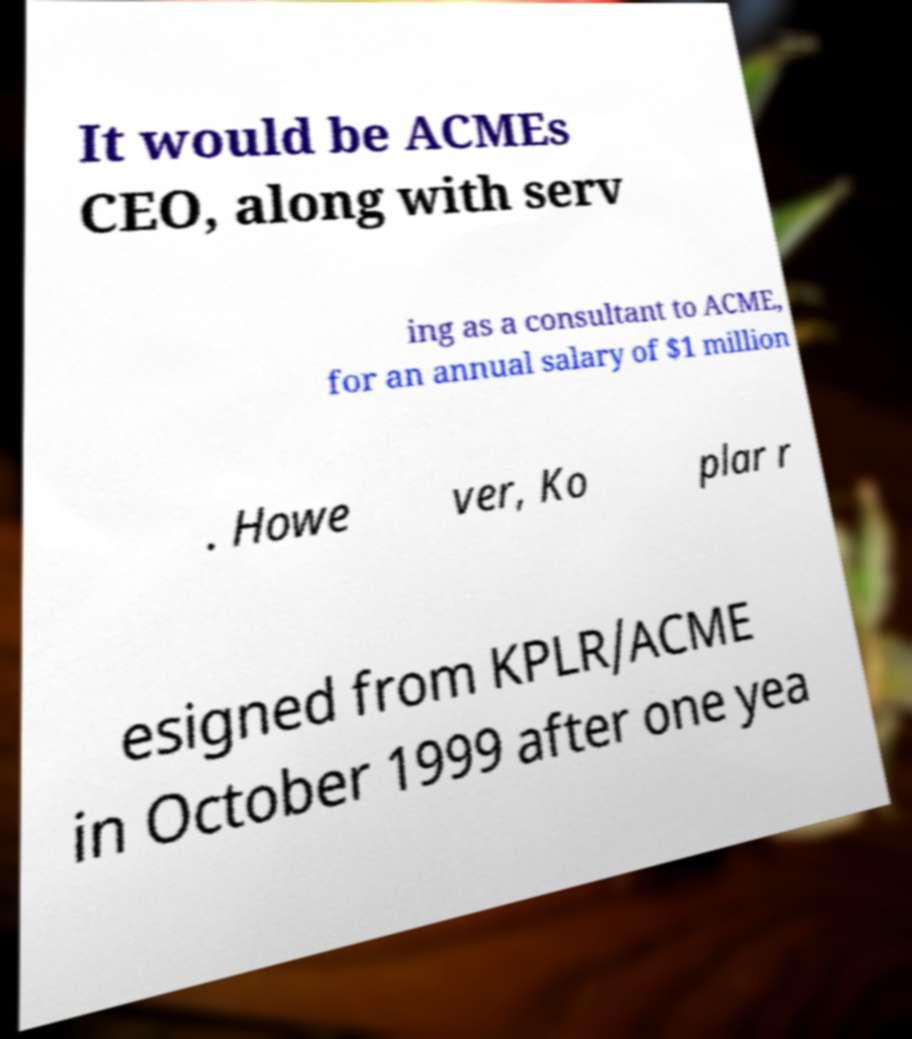Can you read and provide the text displayed in the image?This photo seems to have some interesting text. Can you extract and type it out for me? It would be ACMEs CEO, along with serv ing as a consultant to ACME, for an annual salary of $1 million . Howe ver, Ko plar r esigned from KPLR/ACME in October 1999 after one yea 